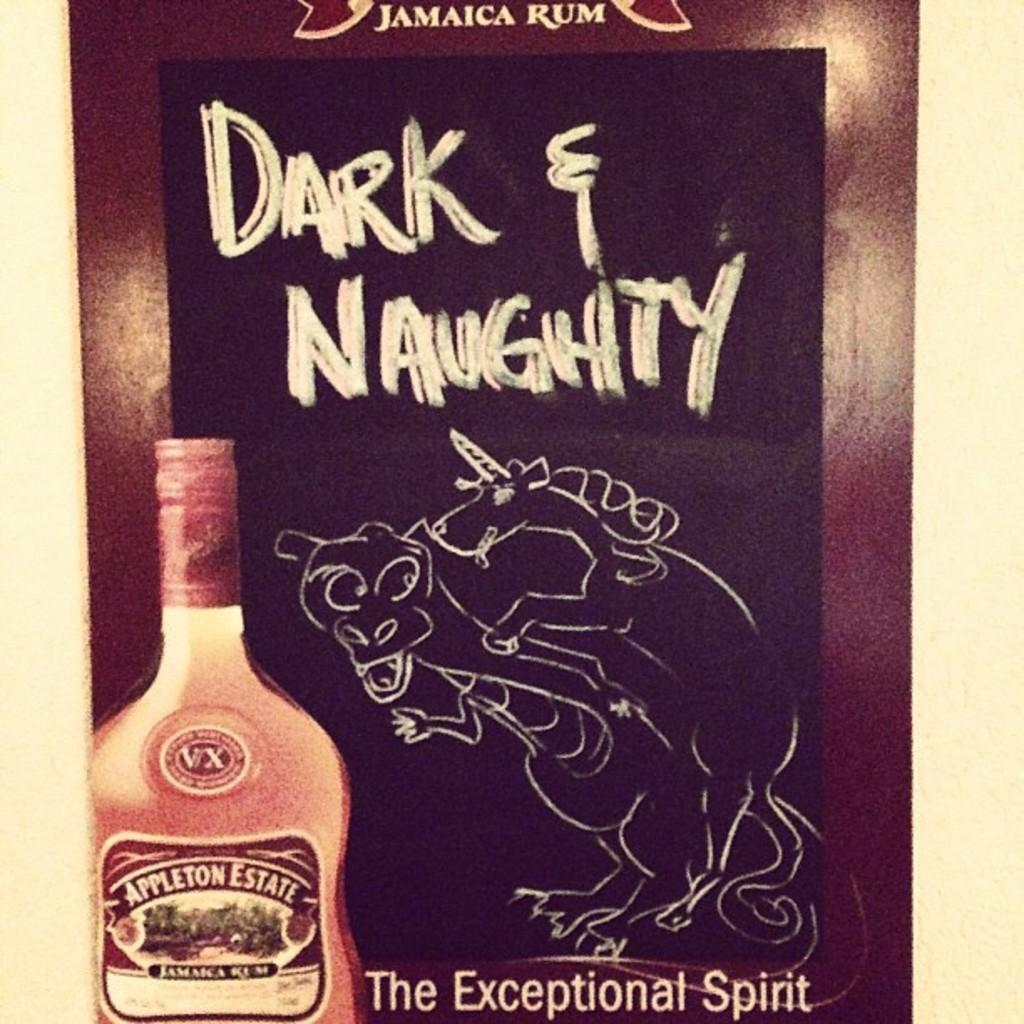<image>
Give a short and clear explanation of the subsequent image. A chalkboard has a drawing of a unicorn and dragon on it with the words "Dark & Naughty" above them. 